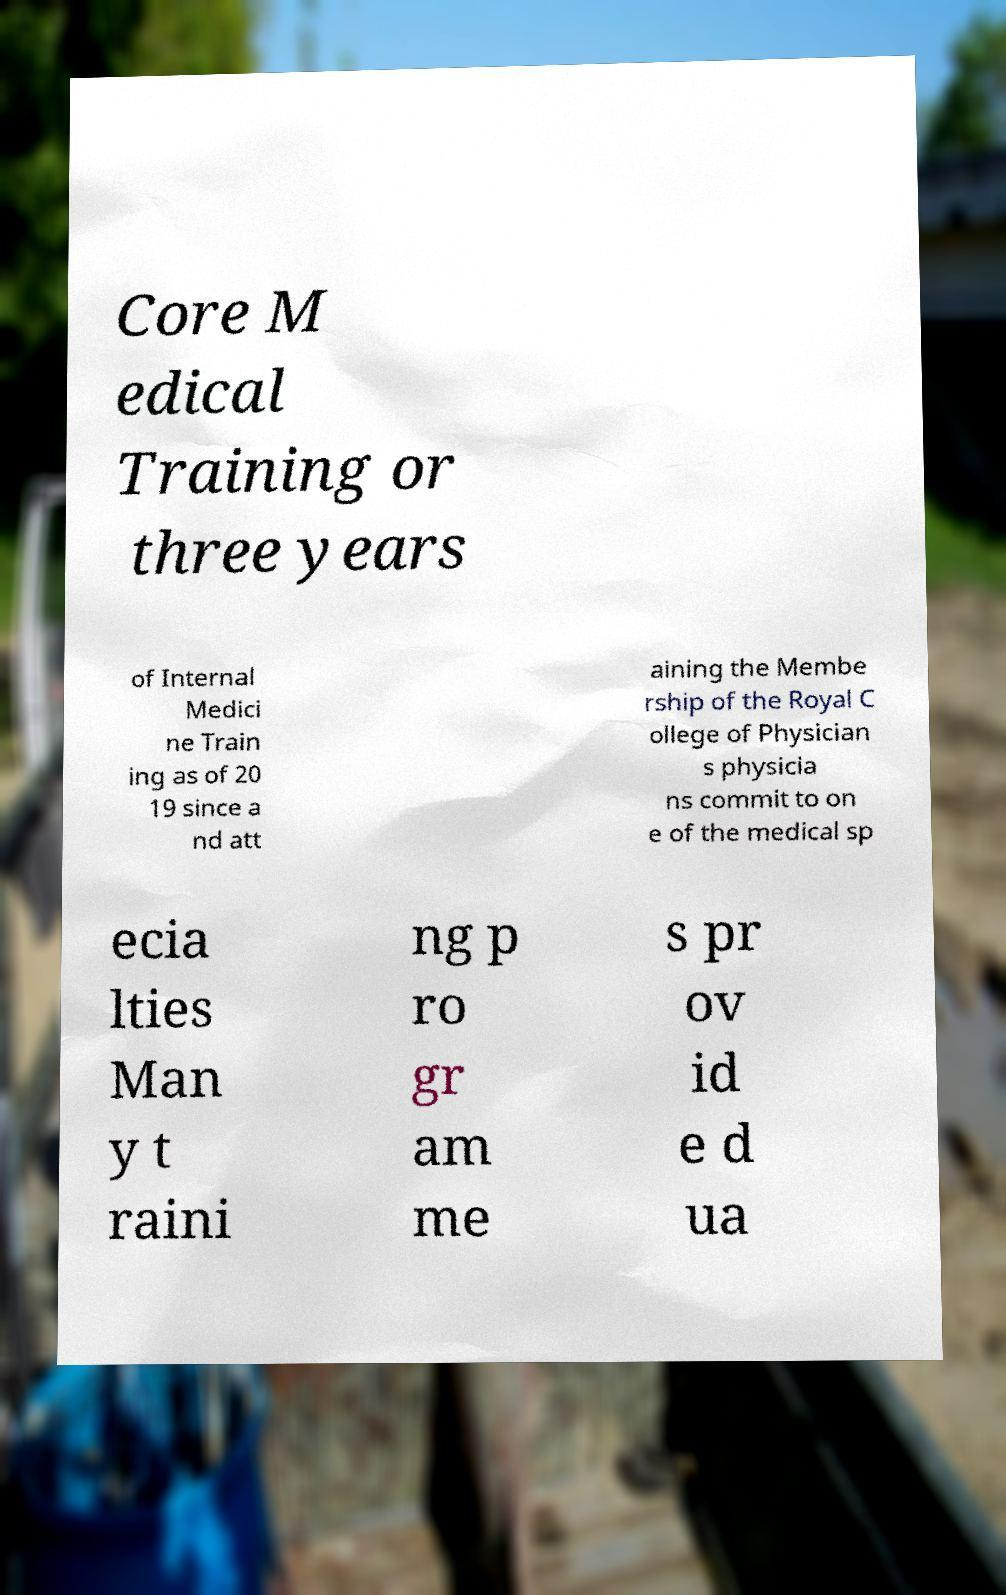Please identify and transcribe the text found in this image. Core M edical Training or three years of Internal Medici ne Train ing as of 20 19 since a nd att aining the Membe rship of the Royal C ollege of Physician s physicia ns commit to on e of the medical sp ecia lties Man y t raini ng p ro gr am me s pr ov id e d ua 